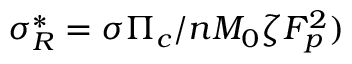Convert formula to latex. <formula><loc_0><loc_0><loc_500><loc_500>\sigma _ { R } ^ { * } = \sigma \Pi _ { c } / n M _ { 0 } \zeta F _ { p } ^ { 2 } )</formula> 